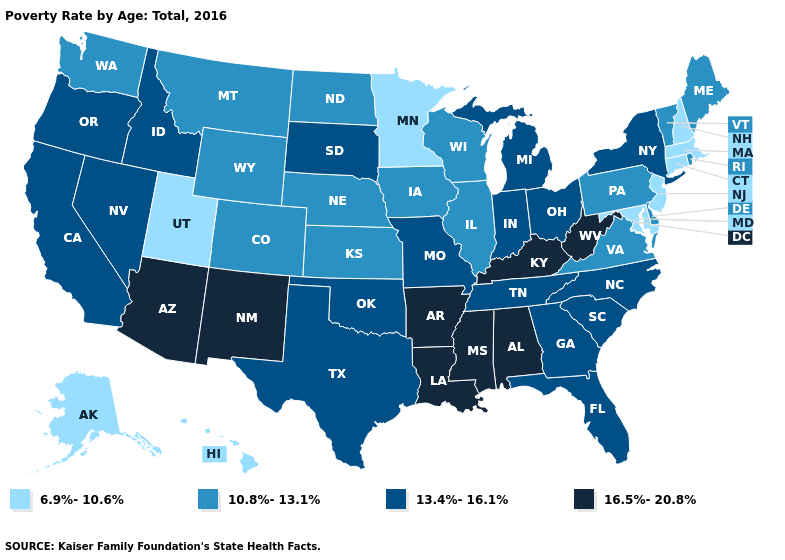Does New York have the highest value in the Northeast?
Quick response, please. Yes. Name the states that have a value in the range 10.8%-13.1%?
Concise answer only. Colorado, Delaware, Illinois, Iowa, Kansas, Maine, Montana, Nebraska, North Dakota, Pennsylvania, Rhode Island, Vermont, Virginia, Washington, Wisconsin, Wyoming. What is the value of Hawaii?
Keep it brief. 6.9%-10.6%. Which states hav the highest value in the MidWest?
Give a very brief answer. Indiana, Michigan, Missouri, Ohio, South Dakota. What is the value of Pennsylvania?
Short answer required. 10.8%-13.1%. Does the map have missing data?
Concise answer only. No. Name the states that have a value in the range 6.9%-10.6%?
Be succinct. Alaska, Connecticut, Hawaii, Maryland, Massachusetts, Minnesota, New Hampshire, New Jersey, Utah. What is the value of Delaware?
Short answer required. 10.8%-13.1%. What is the highest value in states that border Alabama?
Quick response, please. 16.5%-20.8%. Is the legend a continuous bar?
Keep it brief. No. Does the first symbol in the legend represent the smallest category?
Be succinct. Yes. Name the states that have a value in the range 6.9%-10.6%?
Quick response, please. Alaska, Connecticut, Hawaii, Maryland, Massachusetts, Minnesota, New Hampshire, New Jersey, Utah. What is the lowest value in the West?
Answer briefly. 6.9%-10.6%. What is the value of North Carolina?
Keep it brief. 13.4%-16.1%. What is the value of West Virginia?
Answer briefly. 16.5%-20.8%. 